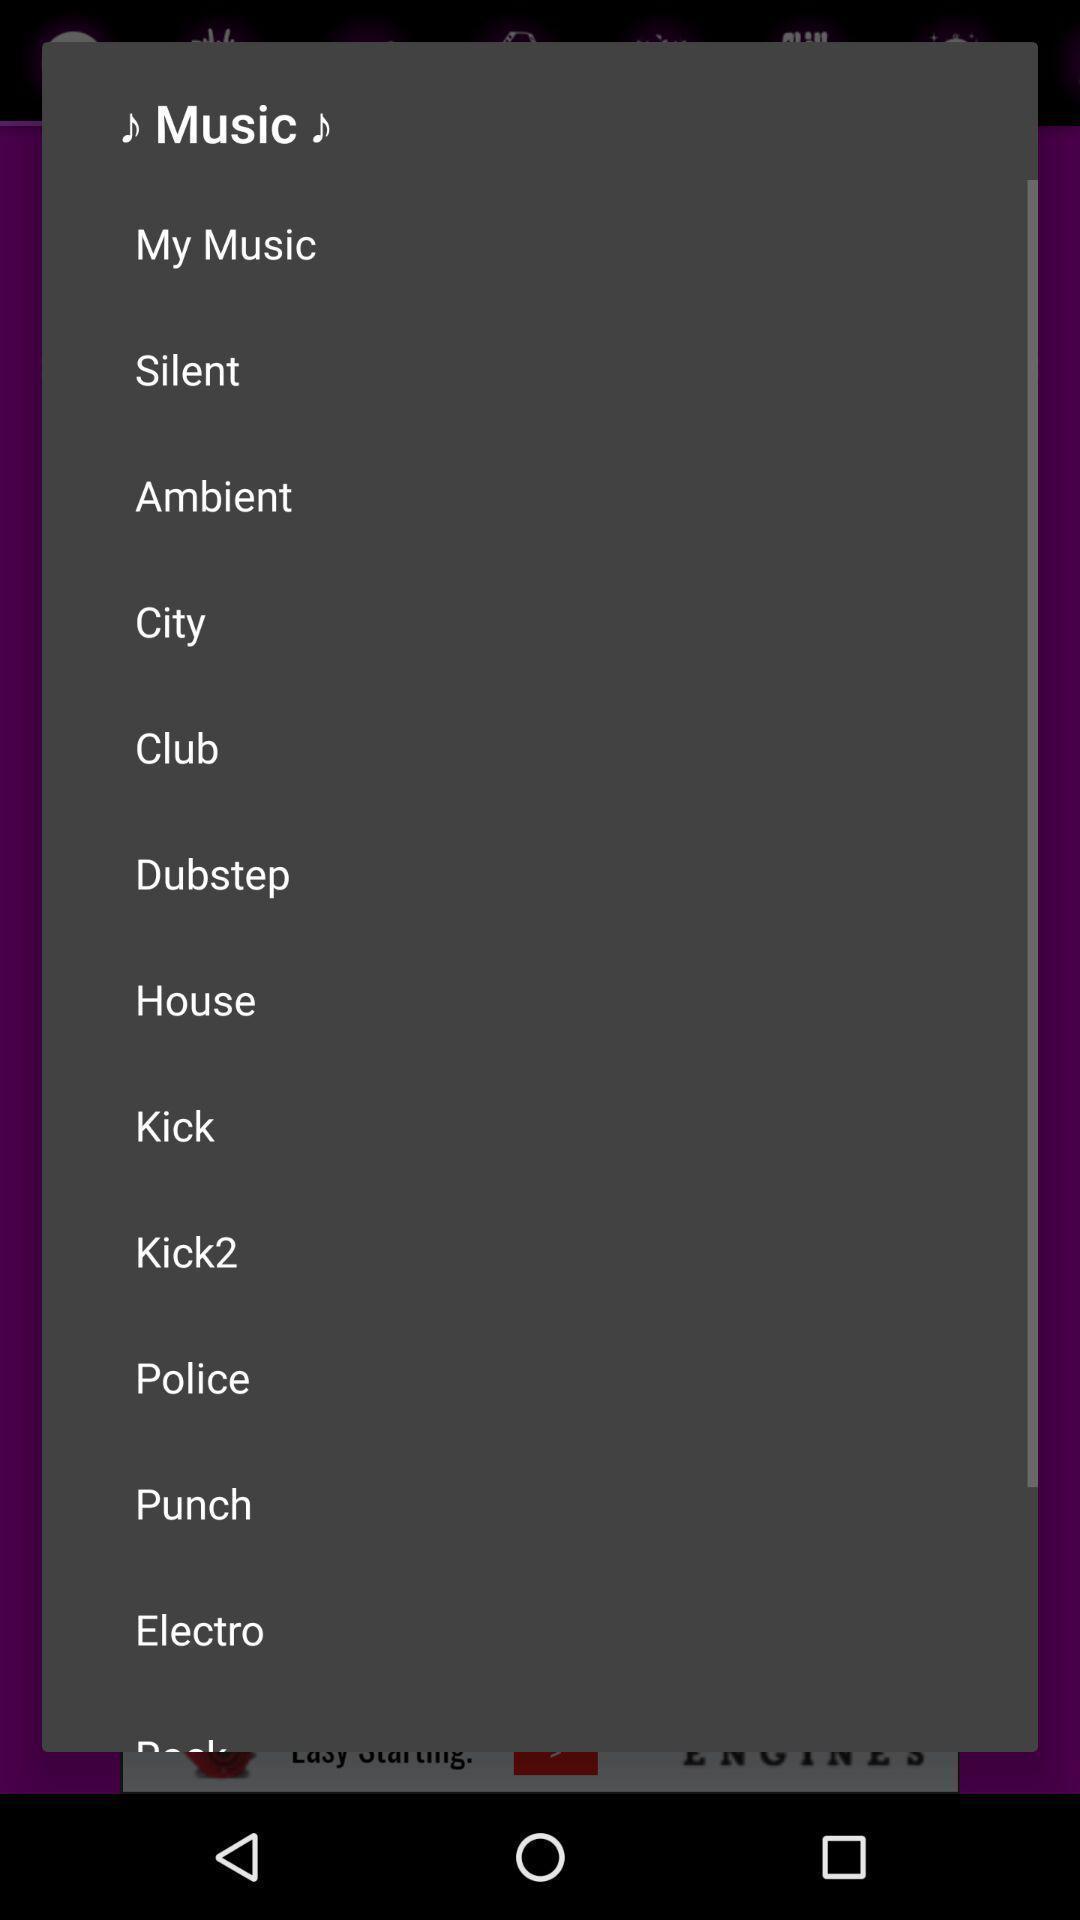Give me a summary of this screen capture. Screen displaying list of music. 